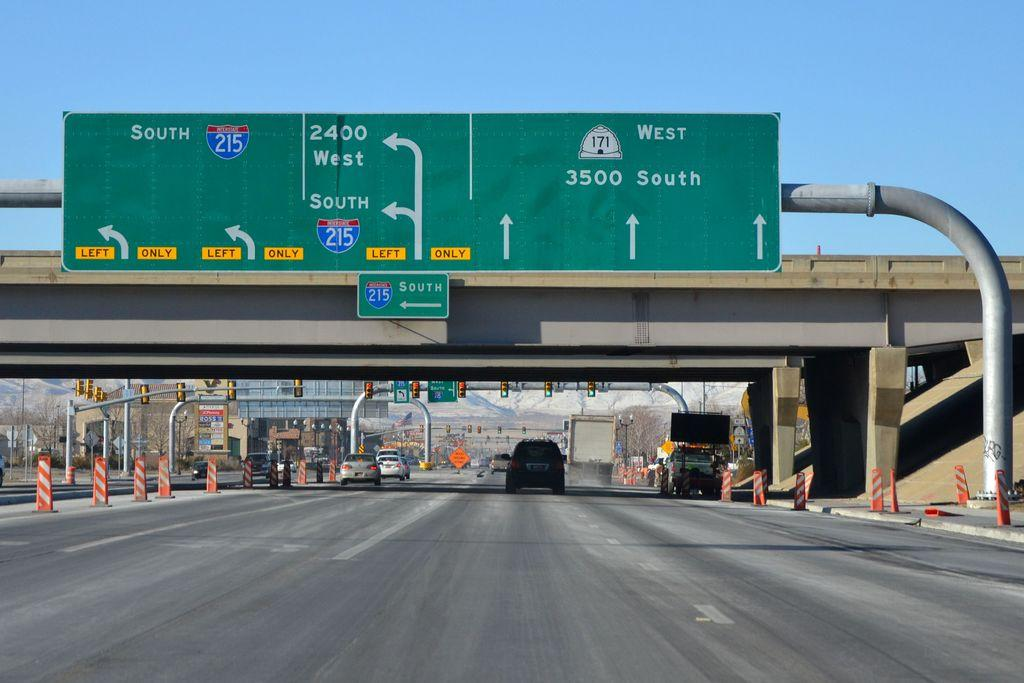<image>
Write a terse but informative summary of the picture. A green street sign shows exits to the west and the south. 